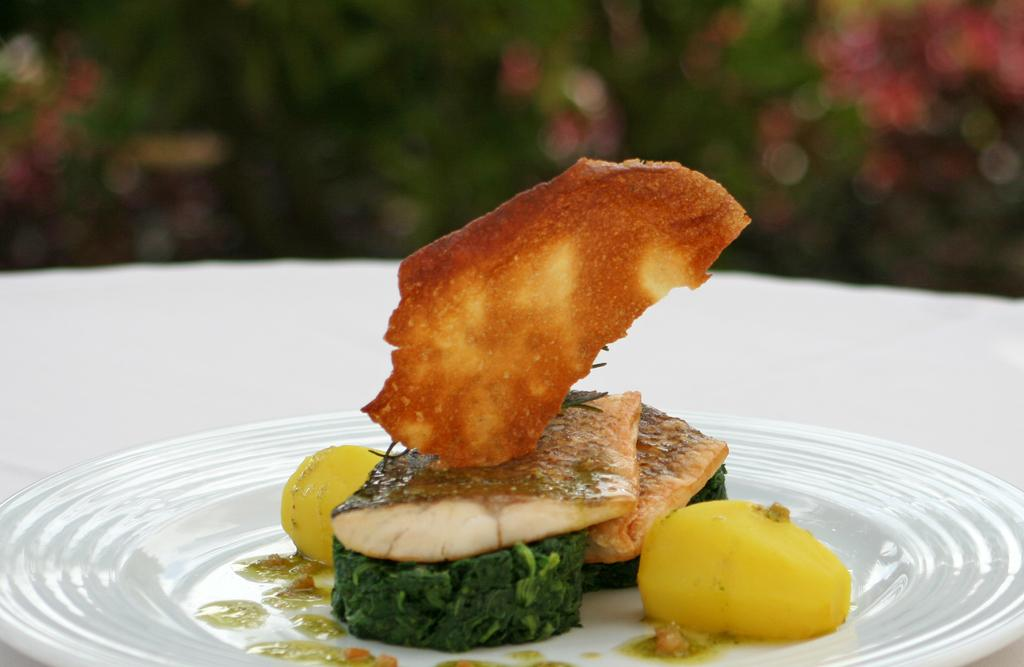What is on the plate in the image? There is food on the plate in the image. Can you describe the background of the image? The background of the image is blurry. How many trees can be seen in the image? There are no trees visible in the image. How many boys are playing in the station in the image? There is no station or boys present in the image. 